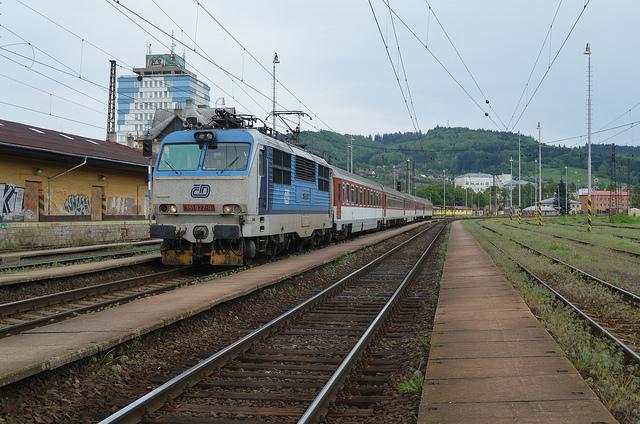Is this a passenger train?
Short answer required. Yes. What colors make up the train?
Concise answer only. White, blue, red. How many tracks are visible?
Write a very short answer. 4. What color is the train engine?
Short answer required. Blue. Is there a train coming?
Answer briefly. Yes. How many wires are above the train tracks?
Answer briefly. 14. What colors of graffiti are on the wall across the tracks?
Short answer required. Blue. Where is the train?
Keep it brief. On tracks. Is this train parked or moving?
Concise answer only. Moving. What is the color of the train on the left?
Quick response, please. Blue. 